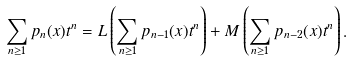Convert formula to latex. <formula><loc_0><loc_0><loc_500><loc_500>\sum _ { n \geq 1 } p _ { n } ( x ) t ^ { n } = L \left ( \sum _ { n \geq 1 } p _ { n - 1 } ( x ) t ^ { n } \right ) + M \left ( \sum _ { n \geq 1 } p _ { n - 2 } ( x ) t ^ { n } \right ) .</formula> 